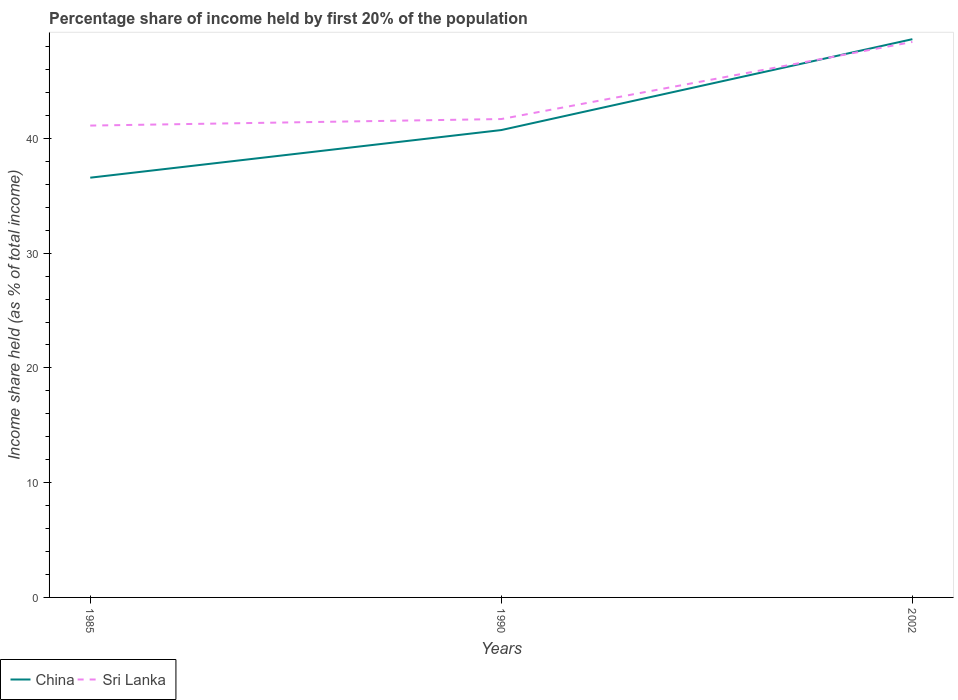How many different coloured lines are there?
Provide a short and direct response. 2. Does the line corresponding to Sri Lanka intersect with the line corresponding to China?
Provide a short and direct response. Yes. Across all years, what is the maximum share of income held by first 20% of the population in China?
Ensure brevity in your answer.  36.58. What is the total share of income held by first 20% of the population in China in the graph?
Give a very brief answer. -12.07. What is the difference between the highest and the second highest share of income held by first 20% of the population in China?
Offer a very short reply. 12.07. What is the difference between the highest and the lowest share of income held by first 20% of the population in China?
Provide a short and direct response. 1. How many lines are there?
Your answer should be very brief. 2. What is the difference between two consecutive major ticks on the Y-axis?
Offer a terse response. 10. Does the graph contain grids?
Your answer should be compact. No. What is the title of the graph?
Make the answer very short. Percentage share of income held by first 20% of the population. What is the label or title of the Y-axis?
Your response must be concise. Income share held (as % of total income). What is the Income share held (as % of total income) of China in 1985?
Your answer should be compact. 36.58. What is the Income share held (as % of total income) in Sri Lanka in 1985?
Ensure brevity in your answer.  41.12. What is the Income share held (as % of total income) in China in 1990?
Offer a very short reply. 40.73. What is the Income share held (as % of total income) in Sri Lanka in 1990?
Give a very brief answer. 41.69. What is the Income share held (as % of total income) of China in 2002?
Your response must be concise. 48.65. What is the Income share held (as % of total income) of Sri Lanka in 2002?
Your answer should be compact. 48.41. Across all years, what is the maximum Income share held (as % of total income) in China?
Make the answer very short. 48.65. Across all years, what is the maximum Income share held (as % of total income) in Sri Lanka?
Keep it short and to the point. 48.41. Across all years, what is the minimum Income share held (as % of total income) in China?
Ensure brevity in your answer.  36.58. Across all years, what is the minimum Income share held (as % of total income) in Sri Lanka?
Your answer should be compact. 41.12. What is the total Income share held (as % of total income) of China in the graph?
Offer a very short reply. 125.96. What is the total Income share held (as % of total income) in Sri Lanka in the graph?
Give a very brief answer. 131.22. What is the difference between the Income share held (as % of total income) in China in 1985 and that in 1990?
Provide a short and direct response. -4.15. What is the difference between the Income share held (as % of total income) in Sri Lanka in 1985 and that in 1990?
Provide a succinct answer. -0.57. What is the difference between the Income share held (as % of total income) of China in 1985 and that in 2002?
Offer a terse response. -12.07. What is the difference between the Income share held (as % of total income) of Sri Lanka in 1985 and that in 2002?
Give a very brief answer. -7.29. What is the difference between the Income share held (as % of total income) of China in 1990 and that in 2002?
Offer a terse response. -7.92. What is the difference between the Income share held (as % of total income) in Sri Lanka in 1990 and that in 2002?
Give a very brief answer. -6.72. What is the difference between the Income share held (as % of total income) in China in 1985 and the Income share held (as % of total income) in Sri Lanka in 1990?
Make the answer very short. -5.11. What is the difference between the Income share held (as % of total income) in China in 1985 and the Income share held (as % of total income) in Sri Lanka in 2002?
Give a very brief answer. -11.83. What is the difference between the Income share held (as % of total income) in China in 1990 and the Income share held (as % of total income) in Sri Lanka in 2002?
Ensure brevity in your answer.  -7.68. What is the average Income share held (as % of total income) in China per year?
Your response must be concise. 41.99. What is the average Income share held (as % of total income) of Sri Lanka per year?
Keep it short and to the point. 43.74. In the year 1985, what is the difference between the Income share held (as % of total income) of China and Income share held (as % of total income) of Sri Lanka?
Your response must be concise. -4.54. In the year 1990, what is the difference between the Income share held (as % of total income) in China and Income share held (as % of total income) in Sri Lanka?
Give a very brief answer. -0.96. In the year 2002, what is the difference between the Income share held (as % of total income) in China and Income share held (as % of total income) in Sri Lanka?
Your answer should be very brief. 0.24. What is the ratio of the Income share held (as % of total income) in China in 1985 to that in 1990?
Your answer should be very brief. 0.9. What is the ratio of the Income share held (as % of total income) of Sri Lanka in 1985 to that in 1990?
Give a very brief answer. 0.99. What is the ratio of the Income share held (as % of total income) of China in 1985 to that in 2002?
Provide a short and direct response. 0.75. What is the ratio of the Income share held (as % of total income) of Sri Lanka in 1985 to that in 2002?
Your response must be concise. 0.85. What is the ratio of the Income share held (as % of total income) in China in 1990 to that in 2002?
Your answer should be compact. 0.84. What is the ratio of the Income share held (as % of total income) of Sri Lanka in 1990 to that in 2002?
Make the answer very short. 0.86. What is the difference between the highest and the second highest Income share held (as % of total income) of China?
Give a very brief answer. 7.92. What is the difference between the highest and the second highest Income share held (as % of total income) of Sri Lanka?
Your answer should be very brief. 6.72. What is the difference between the highest and the lowest Income share held (as % of total income) in China?
Offer a very short reply. 12.07. What is the difference between the highest and the lowest Income share held (as % of total income) of Sri Lanka?
Your answer should be very brief. 7.29. 